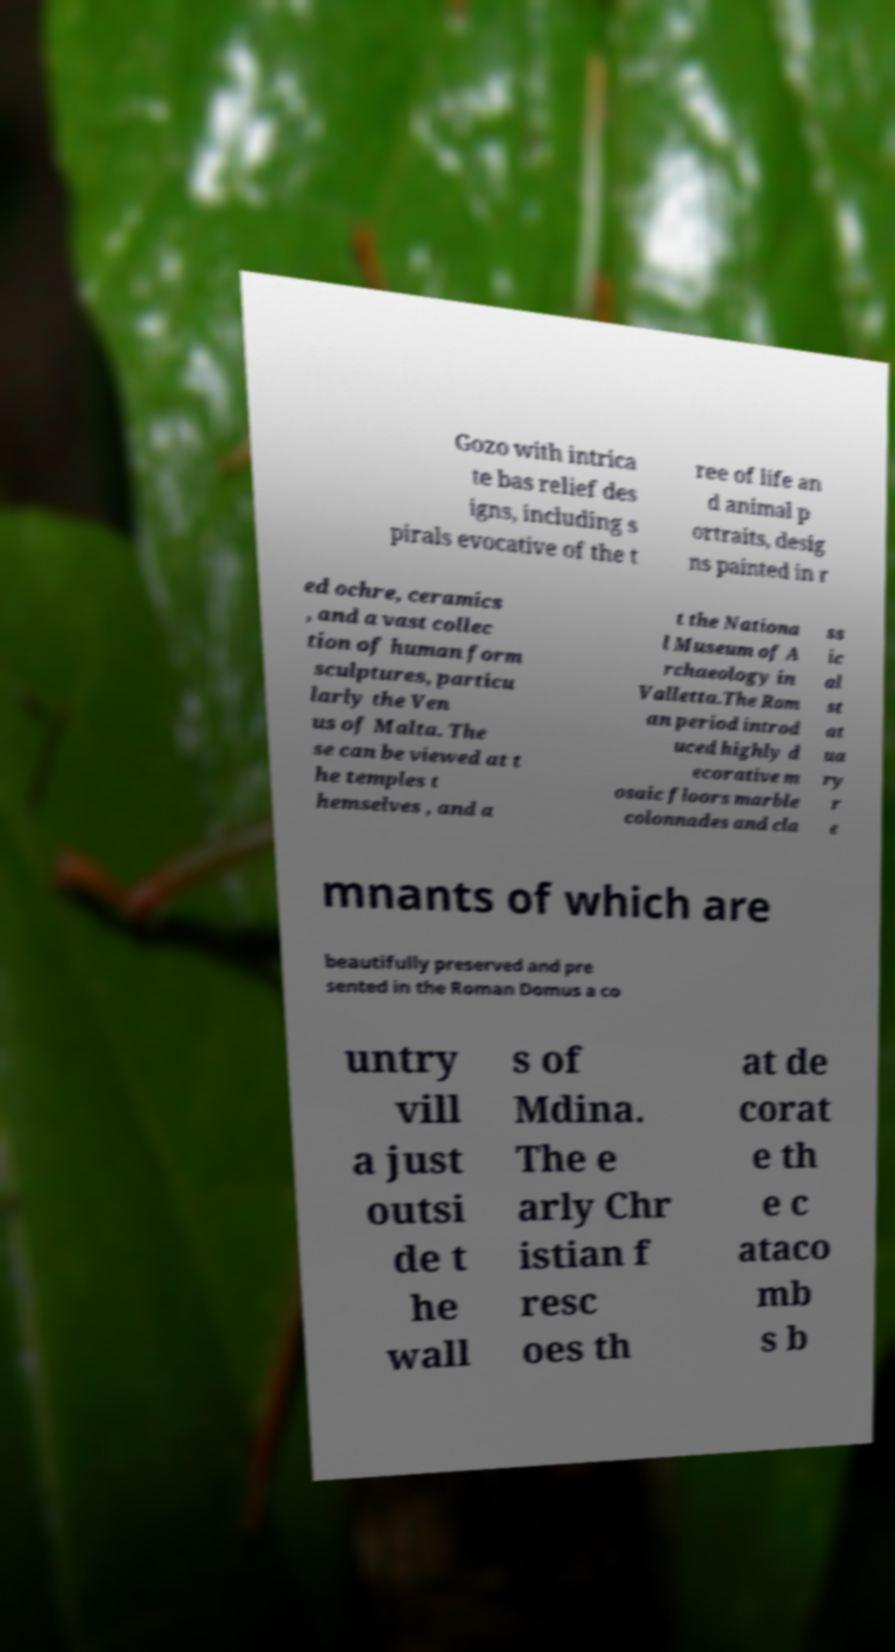There's text embedded in this image that I need extracted. Can you transcribe it verbatim? Gozo with intrica te bas relief des igns, including s pirals evocative of the t ree of life an d animal p ortraits, desig ns painted in r ed ochre, ceramics , and a vast collec tion of human form sculptures, particu larly the Ven us of Malta. The se can be viewed at t he temples t hemselves , and a t the Nationa l Museum of A rchaeology in Valletta.The Rom an period introd uced highly d ecorative m osaic floors marble colonnades and cla ss ic al st at ua ry r e mnants of which are beautifully preserved and pre sented in the Roman Domus a co untry vill a just outsi de t he wall s of Mdina. The e arly Chr istian f resc oes th at de corat e th e c ataco mb s b 